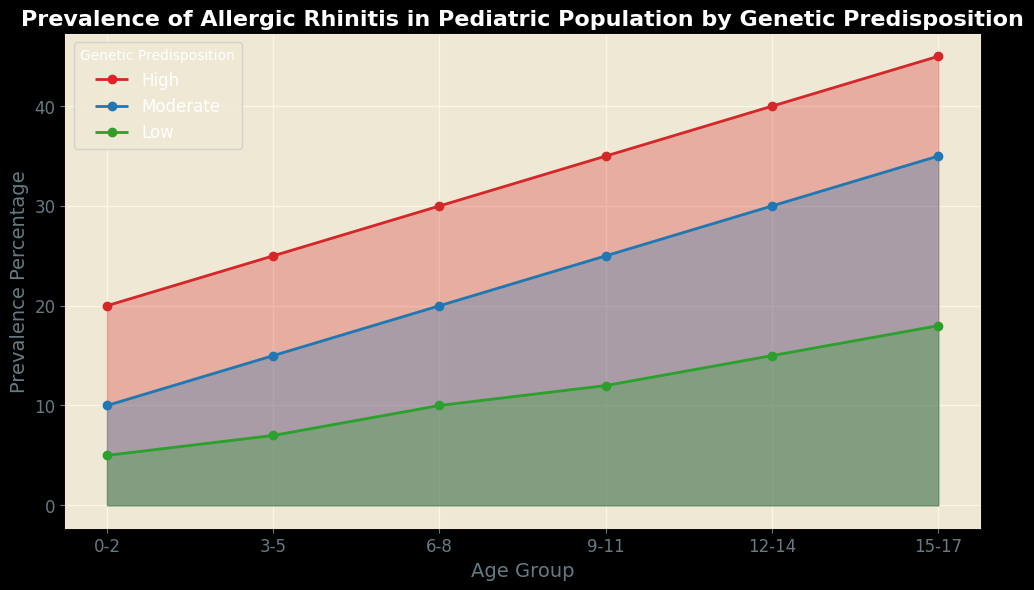What trend can be observed for the prevalence of allergic rhinitis in the high genetic predisposition group across different age groups? The prevalence of allergic rhinitis in the high genetic predisposition group shows a steady increase as age increases. It starts at 20% in the 0-2 age group and rises to 45% in the 15-17 age group.
Answer: Increasing trend Which age group has the lowest prevalence percentage among those with low genetic predisposition? By looking at the green line representing 'Low' genetic predisposition, the lowest prevalence is observed in the 0-2 age group, which is 5%.
Answer: 0-2 Compare the prevalence of allergic rhinitis in the 6-8 age group between high and moderate genetic predisposition. The high genetic predisposition in the 6-8 age group has a prevalence of 30%, whereas the moderate genetic predisposition has a prevalence of 20%.
Answer: High: 30%, Moderate: 20% What is the average prevalence percentage of allergic rhinitis across all age groups for the moderate genetic predisposition? To find the average prevalence percentage for the moderate group, sum the prevalence percentages across all age groups (10 + 15 + 20 + 25 + 30 + 35) and divide by the number of age groups: (10 + 15 + 20 + 25 + 30 + 35) / 6 = 135 / 6 = 22.5
Answer: 22.5% In which age group is the difference in prevalence percentage between high and low genetic predisposition the greatest? By examining each age group, the largest difference is seen in the 15-17 age group, where high genetic predisposition is at 45% and low genetic predisposition is at 18%, giving a difference of 27%.
Answer: 15-17 How does the prevalence percentage for the moderate genetic predisposition in the 3-5 age group compare to the 12-14 age group? The prevalence for the moderate genetic predisposition in the 3-5 age group is 15%, while in the 12-14 age group, it is 30%. The prevalence doubles from 3-5 to 12-14.
Answer: 15% vs 30% Which genetic predisposition group shows the highest increase in prevalence percentage from the 0-2 age group to the 15-17 age group? The high genetic predisposition group shows the highest increase, going from 20% in the 0-2 age group to 45% in the 15-17 age group, which is an increase of 25%.
Answer: High What percentage point difference can be observed in the 9-11 age group between the high and low genetic predisposition groups? In the 9-11 age group, the high genetic predisposition group has a prevalence of 35%, and the low genetic predisposition group has 12%. The difference is 35% - 12% = 23 percentage points.
Answer: 23 percentage points 